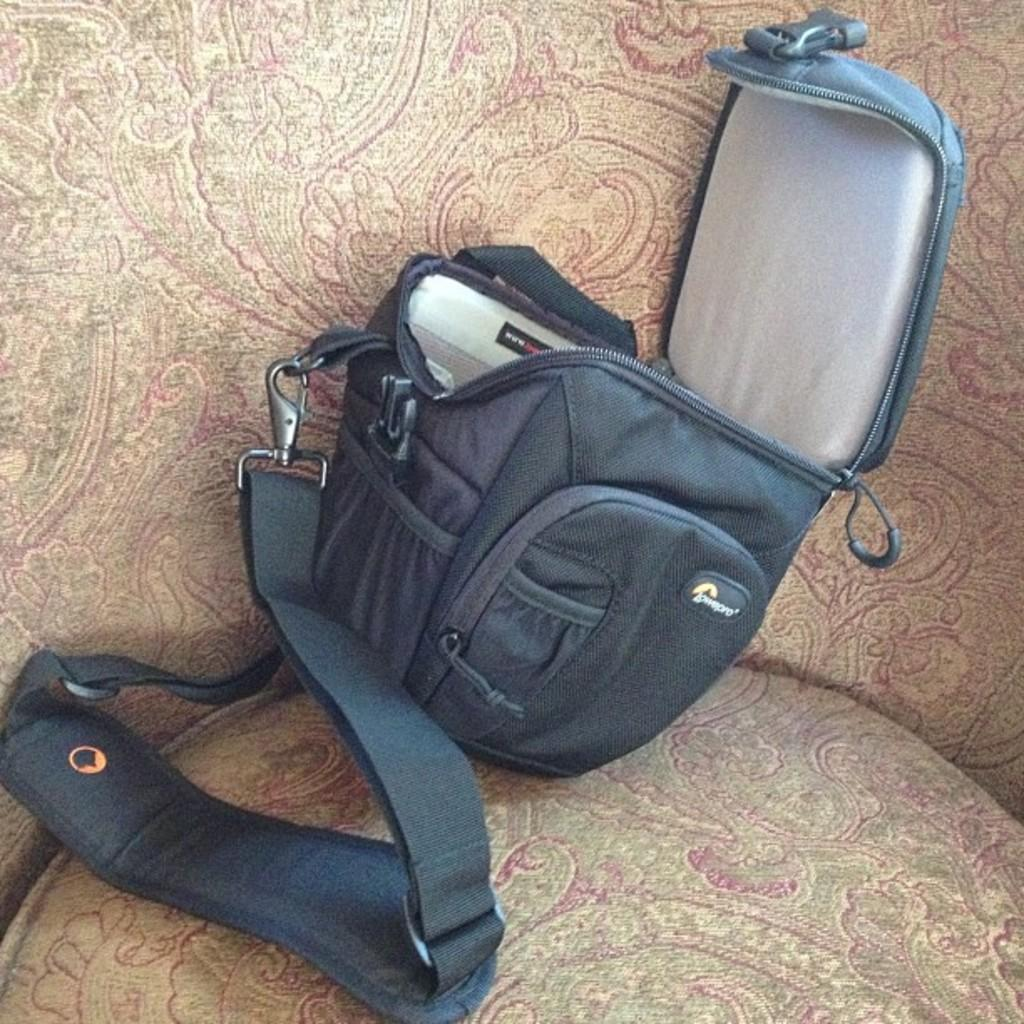What is the main object in the center of the image? There is a bag in the center of the image. What type of furniture is visible at the bottom of the image? There is a table in the bottom of the image. How many clovers are growing on the table in the image? There are no clovers visible on the table in the image. What type of wealth is represented by the bag in the image? The image does not provide any information about the wealth represented by the bag. 